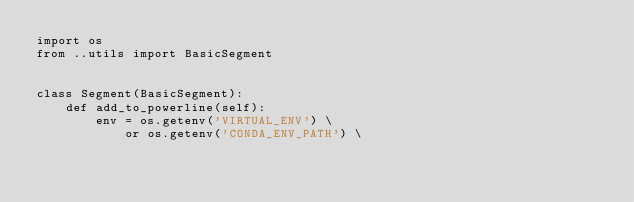<code> <loc_0><loc_0><loc_500><loc_500><_Python_>import os
from ..utils import BasicSegment


class Segment(BasicSegment):
    def add_to_powerline(self):
        env = os.getenv('VIRTUAL_ENV') \
            or os.getenv('CONDA_ENV_PATH') \</code> 